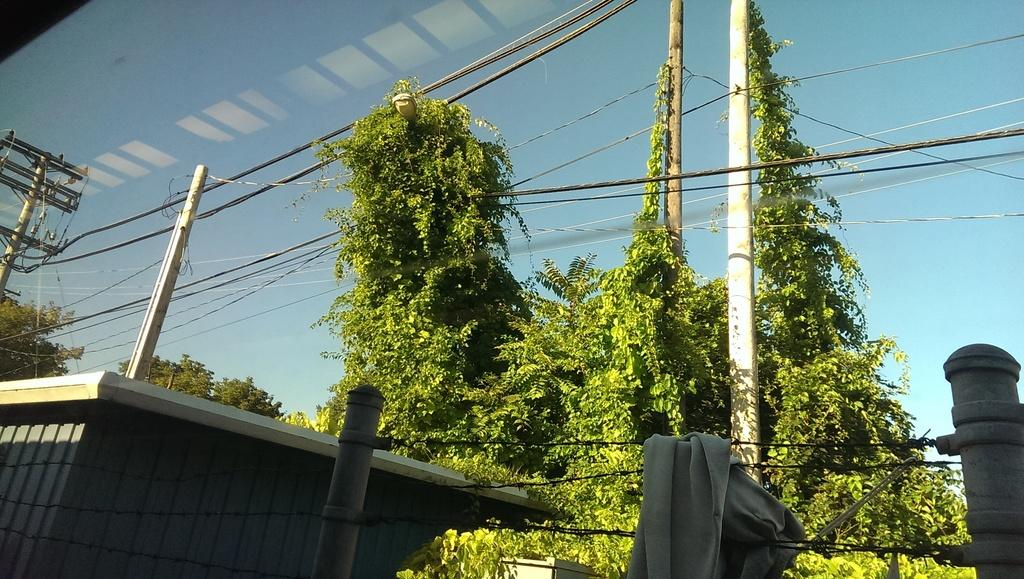What type of structure is present in the image? There is a building in the image. What other objects can be seen in the image? There are poles, wires, trees, and a white-colored cloth on a wire in the image. What is the color of the cloth in the image? The cloth in the image is white. What can be seen in the background of the image? The sky is visible in the background of the image. What type of fiction is being read by the eyes in the image? There are no eyes or fiction present in the image. 